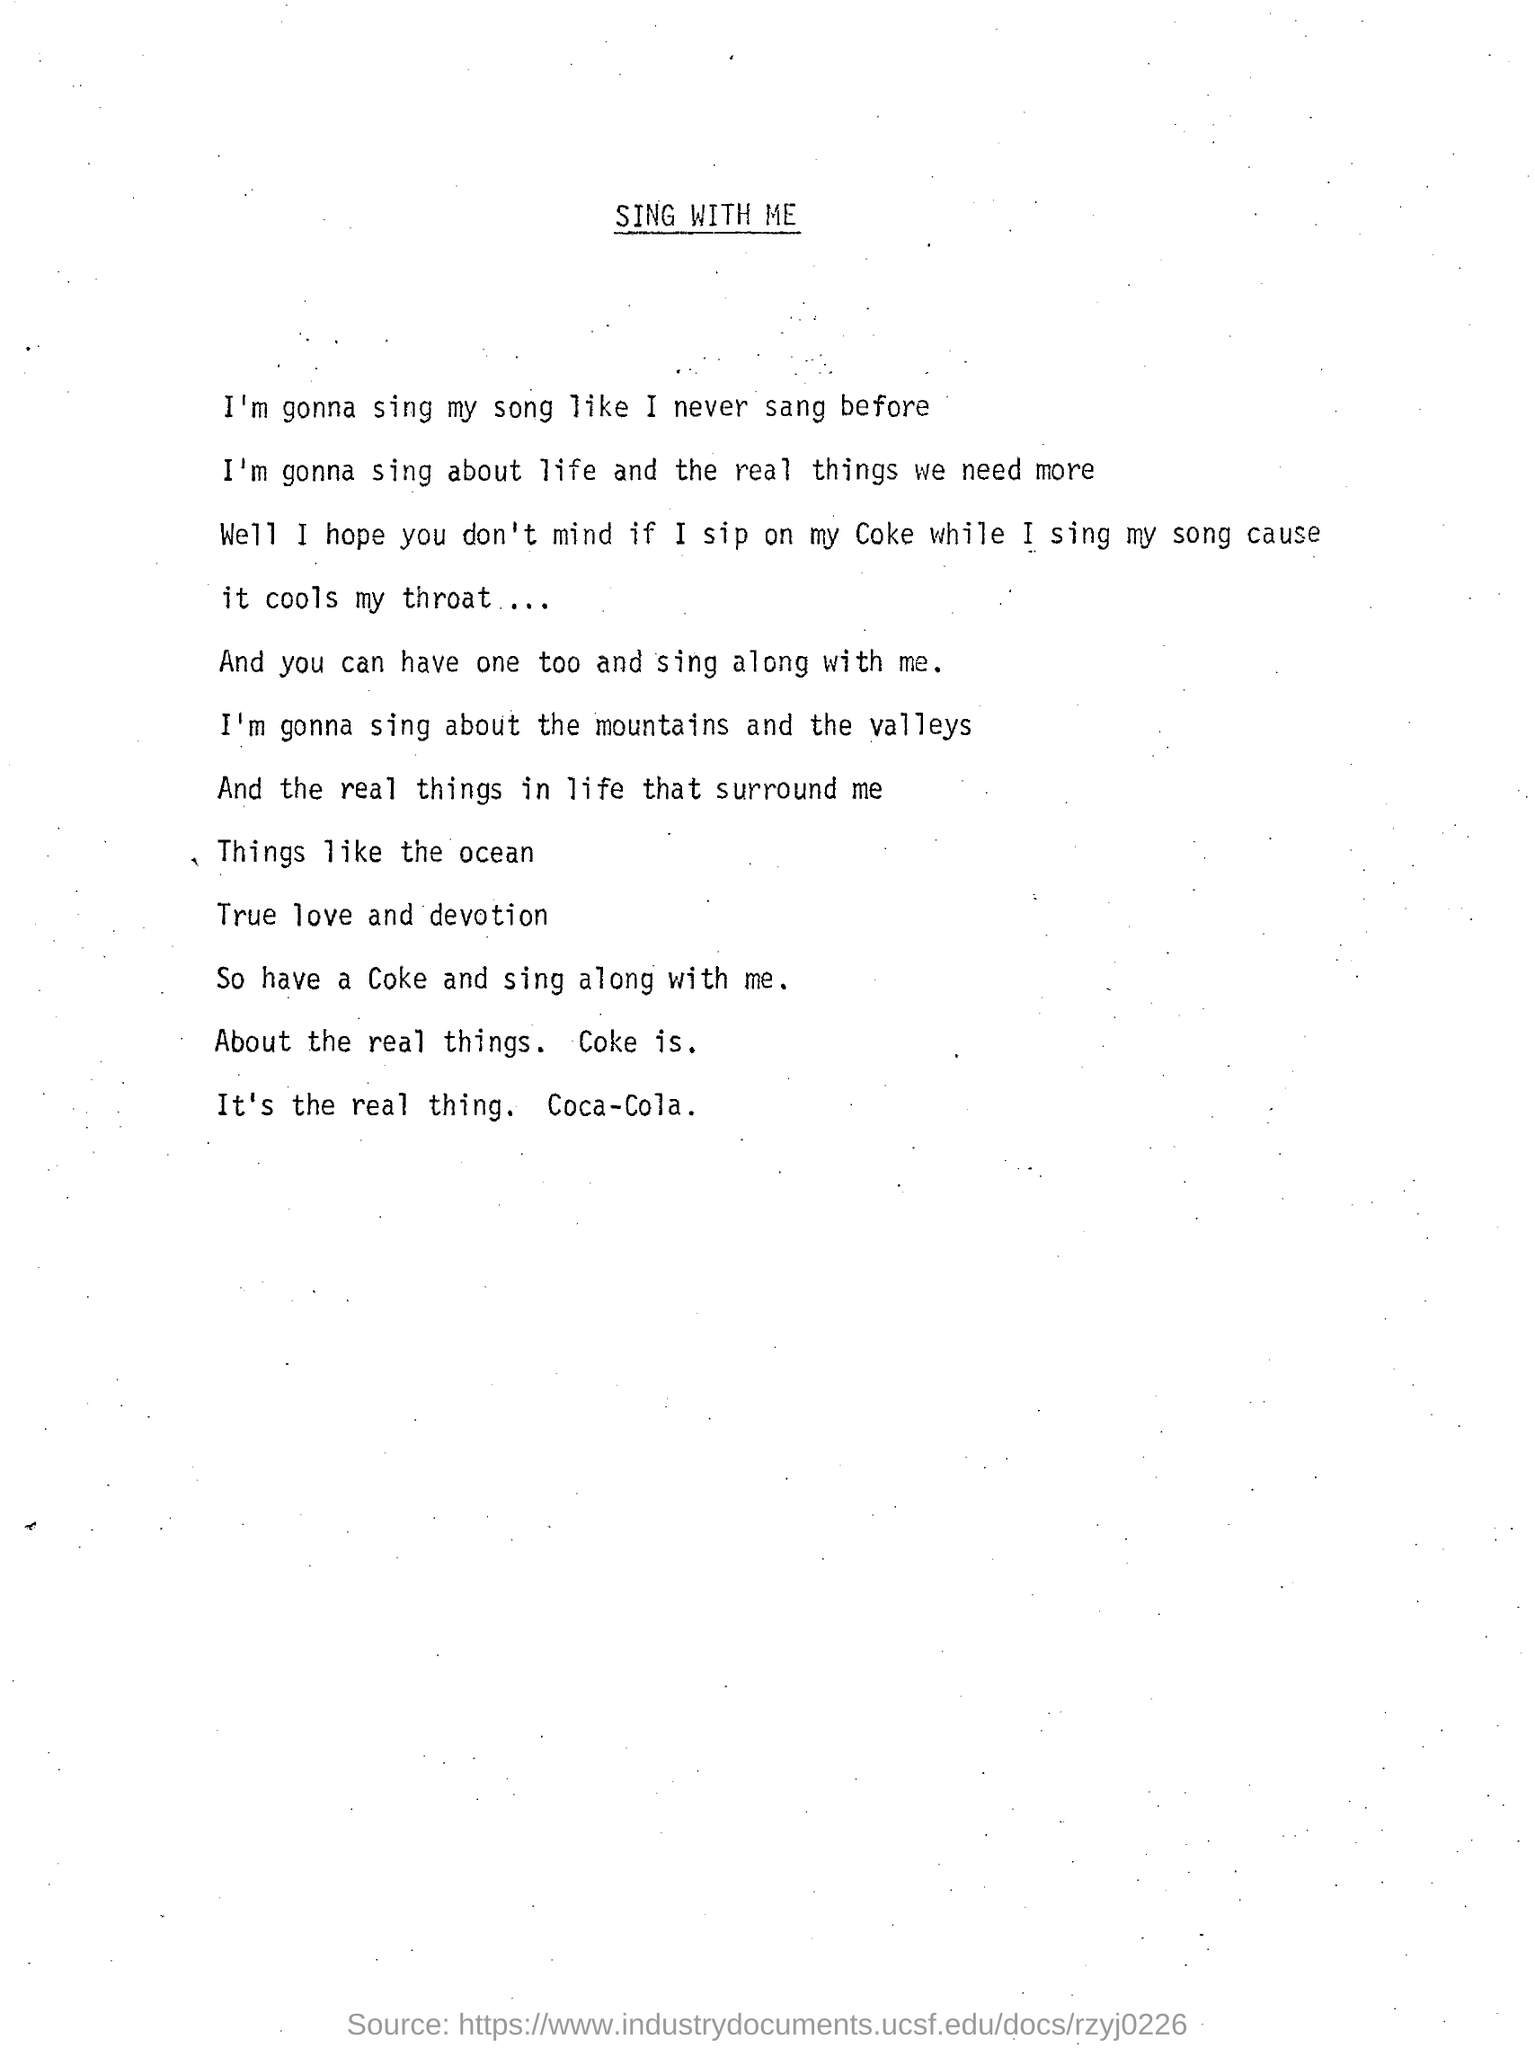Point out several critical features in this image. I have consumed a Coca-Cola beverage while singing my song, and as a result, the carbonation and temperature of the drink have cooled my throat, providing a soothing sensation. The title of the page is 'Sing With Me'. 